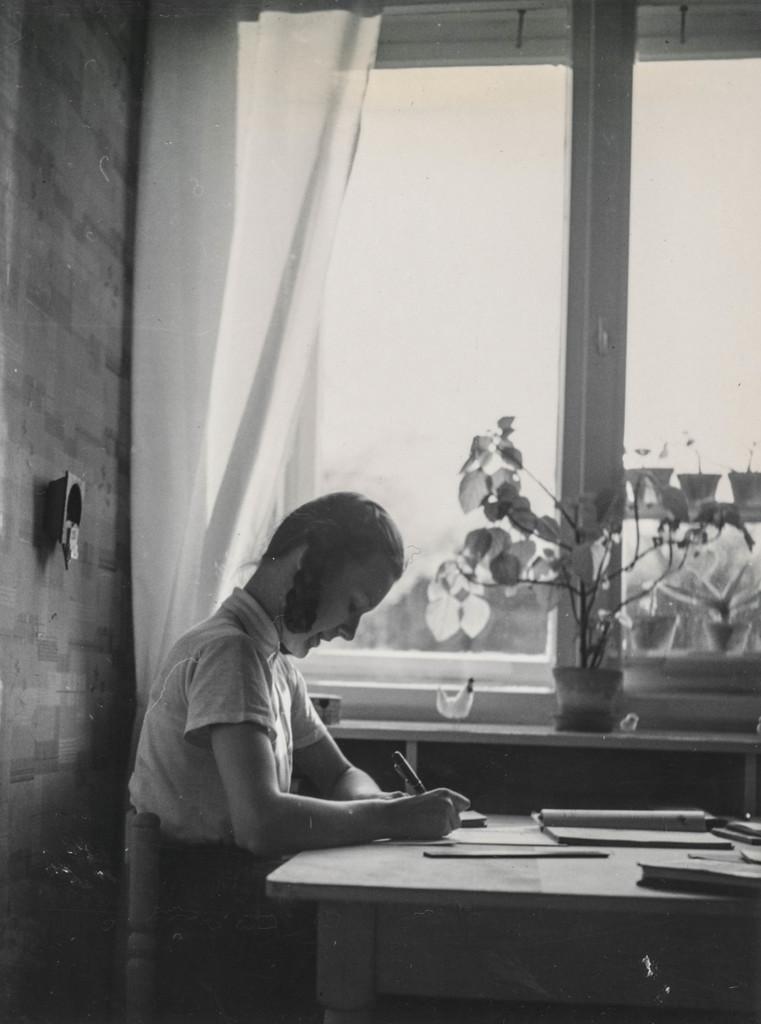In one or two sentences, can you explain what this image depicts? This is of black and white image. There is a girl sitting on the chair and writing. This is a table with books and some other objects on it. This is a house plant which is placed near the window. This is a curtain which is changed through the hanger. This is some kind of object attached to the wall. 